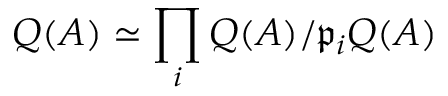<formula> <loc_0><loc_0><loc_500><loc_500>Q ( A ) \simeq \prod _ { i } Q ( A ) / { \mathfrak { p } } _ { i } Q ( A )</formula> 